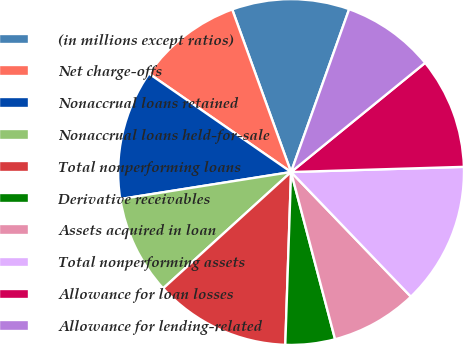Convert chart to OTSL. <chart><loc_0><loc_0><loc_500><loc_500><pie_chart><fcel>(in millions except ratios)<fcel>Net charge-offs<fcel>Nonaccrual loans retained<fcel>Nonaccrual loans held-for-sale<fcel>Total nonperforming loans<fcel>Derivative receivables<fcel>Assets acquired in loan<fcel>Total nonperforming assets<fcel>Allowance for loan losses<fcel>Allowance for lending-related<nl><fcel>10.98%<fcel>9.83%<fcel>12.14%<fcel>9.25%<fcel>12.72%<fcel>4.63%<fcel>8.09%<fcel>13.29%<fcel>10.4%<fcel>8.67%<nl></chart> 